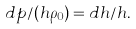<formula> <loc_0><loc_0><loc_500><loc_500>d p / ( h \rho _ { 0 } ) = d h / h .</formula> 